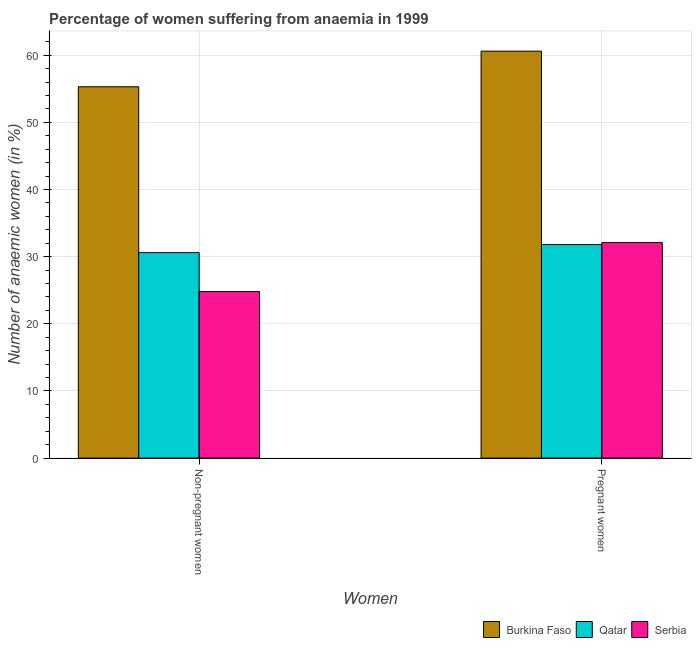Are the number of bars per tick equal to the number of legend labels?
Keep it short and to the point. Yes. How many bars are there on the 1st tick from the left?
Offer a terse response. 3. What is the label of the 1st group of bars from the left?
Ensure brevity in your answer.  Non-pregnant women. What is the percentage of non-pregnant anaemic women in Burkina Faso?
Ensure brevity in your answer.  55.3. Across all countries, what is the maximum percentage of pregnant anaemic women?
Make the answer very short. 60.6. Across all countries, what is the minimum percentage of non-pregnant anaemic women?
Provide a short and direct response. 24.8. In which country was the percentage of pregnant anaemic women maximum?
Offer a terse response. Burkina Faso. In which country was the percentage of non-pregnant anaemic women minimum?
Your response must be concise. Serbia. What is the total percentage of non-pregnant anaemic women in the graph?
Ensure brevity in your answer.  110.7. What is the difference between the percentage of pregnant anaemic women in Serbia and that in Burkina Faso?
Offer a very short reply. -28.5. What is the difference between the percentage of non-pregnant anaemic women in Burkina Faso and the percentage of pregnant anaemic women in Qatar?
Provide a succinct answer. 23.5. What is the average percentage of non-pregnant anaemic women per country?
Make the answer very short. 36.9. What is the difference between the percentage of pregnant anaemic women and percentage of non-pregnant anaemic women in Burkina Faso?
Offer a terse response. 5.3. In how many countries, is the percentage of non-pregnant anaemic women greater than 54 %?
Make the answer very short. 1. What is the ratio of the percentage of non-pregnant anaemic women in Serbia to that in Qatar?
Make the answer very short. 0.81. What does the 3rd bar from the left in Non-pregnant women represents?
Provide a succinct answer. Serbia. What does the 1st bar from the right in Pregnant women represents?
Make the answer very short. Serbia. Are the values on the major ticks of Y-axis written in scientific E-notation?
Your response must be concise. No. Where does the legend appear in the graph?
Your answer should be compact. Bottom right. How many legend labels are there?
Ensure brevity in your answer.  3. How are the legend labels stacked?
Your answer should be compact. Horizontal. What is the title of the graph?
Provide a succinct answer. Percentage of women suffering from anaemia in 1999. Does "Afghanistan" appear as one of the legend labels in the graph?
Your answer should be compact. No. What is the label or title of the X-axis?
Offer a terse response. Women. What is the label or title of the Y-axis?
Your response must be concise. Number of anaemic women (in %). What is the Number of anaemic women (in %) of Burkina Faso in Non-pregnant women?
Provide a succinct answer. 55.3. What is the Number of anaemic women (in %) of Qatar in Non-pregnant women?
Ensure brevity in your answer.  30.6. What is the Number of anaemic women (in %) of Serbia in Non-pregnant women?
Offer a very short reply. 24.8. What is the Number of anaemic women (in %) in Burkina Faso in Pregnant women?
Provide a short and direct response. 60.6. What is the Number of anaemic women (in %) of Qatar in Pregnant women?
Make the answer very short. 31.8. What is the Number of anaemic women (in %) in Serbia in Pregnant women?
Your answer should be compact. 32.1. Across all Women, what is the maximum Number of anaemic women (in %) of Burkina Faso?
Offer a terse response. 60.6. Across all Women, what is the maximum Number of anaemic women (in %) in Qatar?
Your answer should be very brief. 31.8. Across all Women, what is the maximum Number of anaemic women (in %) in Serbia?
Your response must be concise. 32.1. Across all Women, what is the minimum Number of anaemic women (in %) of Burkina Faso?
Your answer should be very brief. 55.3. Across all Women, what is the minimum Number of anaemic women (in %) of Qatar?
Offer a terse response. 30.6. Across all Women, what is the minimum Number of anaemic women (in %) of Serbia?
Provide a succinct answer. 24.8. What is the total Number of anaemic women (in %) of Burkina Faso in the graph?
Give a very brief answer. 115.9. What is the total Number of anaemic women (in %) in Qatar in the graph?
Give a very brief answer. 62.4. What is the total Number of anaemic women (in %) in Serbia in the graph?
Offer a terse response. 56.9. What is the difference between the Number of anaemic women (in %) in Burkina Faso in Non-pregnant women and that in Pregnant women?
Offer a terse response. -5.3. What is the difference between the Number of anaemic women (in %) of Qatar in Non-pregnant women and that in Pregnant women?
Your answer should be compact. -1.2. What is the difference between the Number of anaemic women (in %) in Serbia in Non-pregnant women and that in Pregnant women?
Keep it short and to the point. -7.3. What is the difference between the Number of anaemic women (in %) in Burkina Faso in Non-pregnant women and the Number of anaemic women (in %) in Qatar in Pregnant women?
Provide a succinct answer. 23.5. What is the difference between the Number of anaemic women (in %) in Burkina Faso in Non-pregnant women and the Number of anaemic women (in %) in Serbia in Pregnant women?
Your answer should be very brief. 23.2. What is the average Number of anaemic women (in %) of Burkina Faso per Women?
Make the answer very short. 57.95. What is the average Number of anaemic women (in %) in Qatar per Women?
Make the answer very short. 31.2. What is the average Number of anaemic women (in %) in Serbia per Women?
Make the answer very short. 28.45. What is the difference between the Number of anaemic women (in %) of Burkina Faso and Number of anaemic women (in %) of Qatar in Non-pregnant women?
Your response must be concise. 24.7. What is the difference between the Number of anaemic women (in %) in Burkina Faso and Number of anaemic women (in %) in Serbia in Non-pregnant women?
Make the answer very short. 30.5. What is the difference between the Number of anaemic women (in %) of Qatar and Number of anaemic women (in %) of Serbia in Non-pregnant women?
Your response must be concise. 5.8. What is the difference between the Number of anaemic women (in %) in Burkina Faso and Number of anaemic women (in %) in Qatar in Pregnant women?
Ensure brevity in your answer.  28.8. What is the difference between the Number of anaemic women (in %) of Burkina Faso and Number of anaemic women (in %) of Serbia in Pregnant women?
Provide a succinct answer. 28.5. What is the difference between the Number of anaemic women (in %) in Qatar and Number of anaemic women (in %) in Serbia in Pregnant women?
Make the answer very short. -0.3. What is the ratio of the Number of anaemic women (in %) in Burkina Faso in Non-pregnant women to that in Pregnant women?
Keep it short and to the point. 0.91. What is the ratio of the Number of anaemic women (in %) of Qatar in Non-pregnant women to that in Pregnant women?
Your answer should be compact. 0.96. What is the ratio of the Number of anaemic women (in %) of Serbia in Non-pregnant women to that in Pregnant women?
Provide a short and direct response. 0.77. What is the difference between the highest and the second highest Number of anaemic women (in %) in Serbia?
Provide a short and direct response. 7.3. What is the difference between the highest and the lowest Number of anaemic women (in %) of Serbia?
Your answer should be very brief. 7.3. 